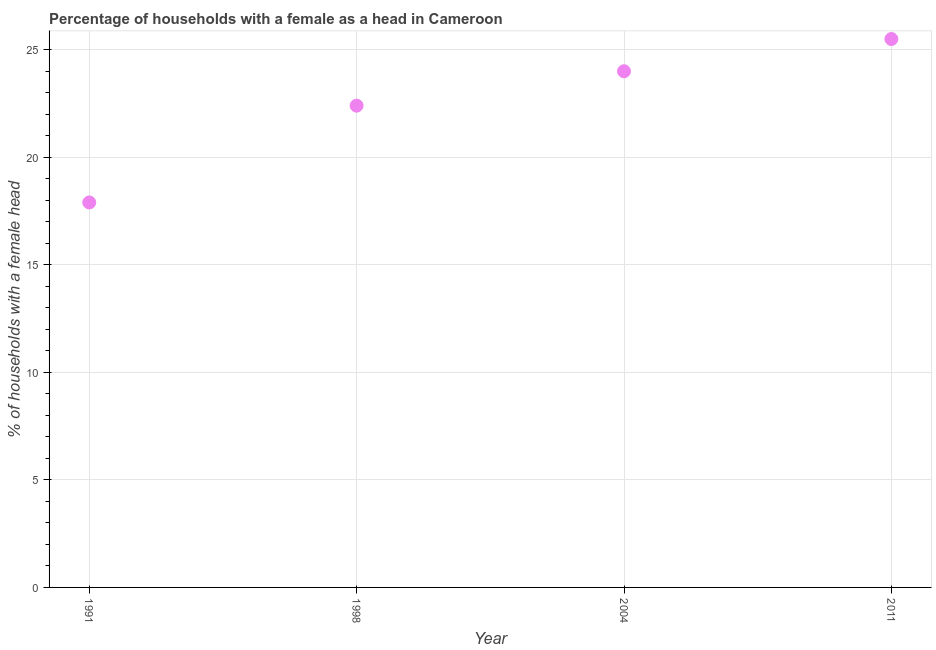Across all years, what is the maximum number of female supervised households?
Offer a terse response. 25.5. In which year was the number of female supervised households minimum?
Provide a succinct answer. 1991. What is the sum of the number of female supervised households?
Ensure brevity in your answer.  89.8. What is the difference between the number of female supervised households in 1991 and 1998?
Offer a terse response. -4.5. What is the average number of female supervised households per year?
Ensure brevity in your answer.  22.45. What is the median number of female supervised households?
Your answer should be very brief. 23.2. Do a majority of the years between 2004 and 2011 (inclusive) have number of female supervised households greater than 15 %?
Give a very brief answer. Yes. What is the ratio of the number of female supervised households in 2004 to that in 2011?
Offer a terse response. 0.94. Is the sum of the number of female supervised households in 1991 and 2011 greater than the maximum number of female supervised households across all years?
Offer a terse response. Yes. What is the difference between the highest and the lowest number of female supervised households?
Keep it short and to the point. 7.6. In how many years, is the number of female supervised households greater than the average number of female supervised households taken over all years?
Your answer should be very brief. 2. Does the number of female supervised households monotonically increase over the years?
Make the answer very short. Yes. How many dotlines are there?
Ensure brevity in your answer.  1. What is the difference between two consecutive major ticks on the Y-axis?
Ensure brevity in your answer.  5. Are the values on the major ticks of Y-axis written in scientific E-notation?
Provide a short and direct response. No. What is the title of the graph?
Offer a terse response. Percentage of households with a female as a head in Cameroon. What is the label or title of the X-axis?
Your answer should be very brief. Year. What is the label or title of the Y-axis?
Offer a terse response. % of households with a female head. What is the % of households with a female head in 1991?
Offer a terse response. 17.9. What is the % of households with a female head in 1998?
Your response must be concise. 22.4. What is the % of households with a female head in 2011?
Keep it short and to the point. 25.5. What is the difference between the % of households with a female head in 1991 and 1998?
Ensure brevity in your answer.  -4.5. What is the difference between the % of households with a female head in 1991 and 2004?
Keep it short and to the point. -6.1. What is the difference between the % of households with a female head in 1991 and 2011?
Keep it short and to the point. -7.6. What is the difference between the % of households with a female head in 2004 and 2011?
Your answer should be very brief. -1.5. What is the ratio of the % of households with a female head in 1991 to that in 1998?
Your answer should be compact. 0.8. What is the ratio of the % of households with a female head in 1991 to that in 2004?
Offer a terse response. 0.75. What is the ratio of the % of households with a female head in 1991 to that in 2011?
Give a very brief answer. 0.7. What is the ratio of the % of households with a female head in 1998 to that in 2004?
Provide a succinct answer. 0.93. What is the ratio of the % of households with a female head in 1998 to that in 2011?
Offer a very short reply. 0.88. What is the ratio of the % of households with a female head in 2004 to that in 2011?
Offer a terse response. 0.94. 